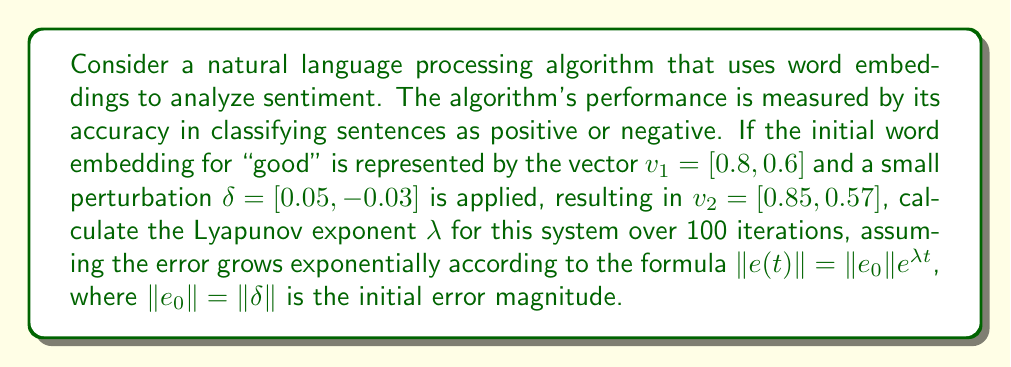Can you answer this question? To solve this problem, we'll follow these steps:

1. Calculate the initial error magnitude $\|e_0\|$:
   $\|e_0\| = \|\delta\| = \sqrt{0.05^2 + (-0.03)^2} = \sqrt{0.0025 + 0.0009} = \sqrt{0.0034} \approx 0.0583$

2. Calculate the final error magnitude after 100 iterations:
   $\|e(100)\| = \|v_2 - v_1\| = \sqrt{(0.85 - 0.8)^2 + (0.57 - 0.6)^2} = \sqrt{0.05^2 + (-0.03)^2} = 0.0583$

3. Use the Lyapunov exponent formula:
   $\|e(t)\| = \|e_0\|e^{\lambda t}$

4. Substitute the known values:
   $0.0583 = 0.0583e^{\lambda \cdot 100}$

5. Solve for $\lambda$:
   $1 = e^{\lambda \cdot 100}$
   $\ln(1) = \lambda \cdot 100$
   $0 = \lambda \cdot 100$
   $\lambda = 0$

The Lyapunov exponent $\lambda$ is 0, indicating that the system is neither expanding nor contracting in phase space over the given time frame.
Answer: $\lambda = 0$ 